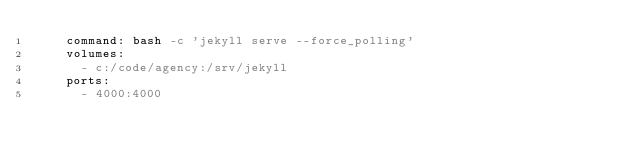Convert code to text. <code><loc_0><loc_0><loc_500><loc_500><_YAML_>    command: bash -c 'jekyll serve --force_polling'
    volumes:
      - c:/code/agency:/srv/jekyll
    ports:
      - 4000:4000</code> 